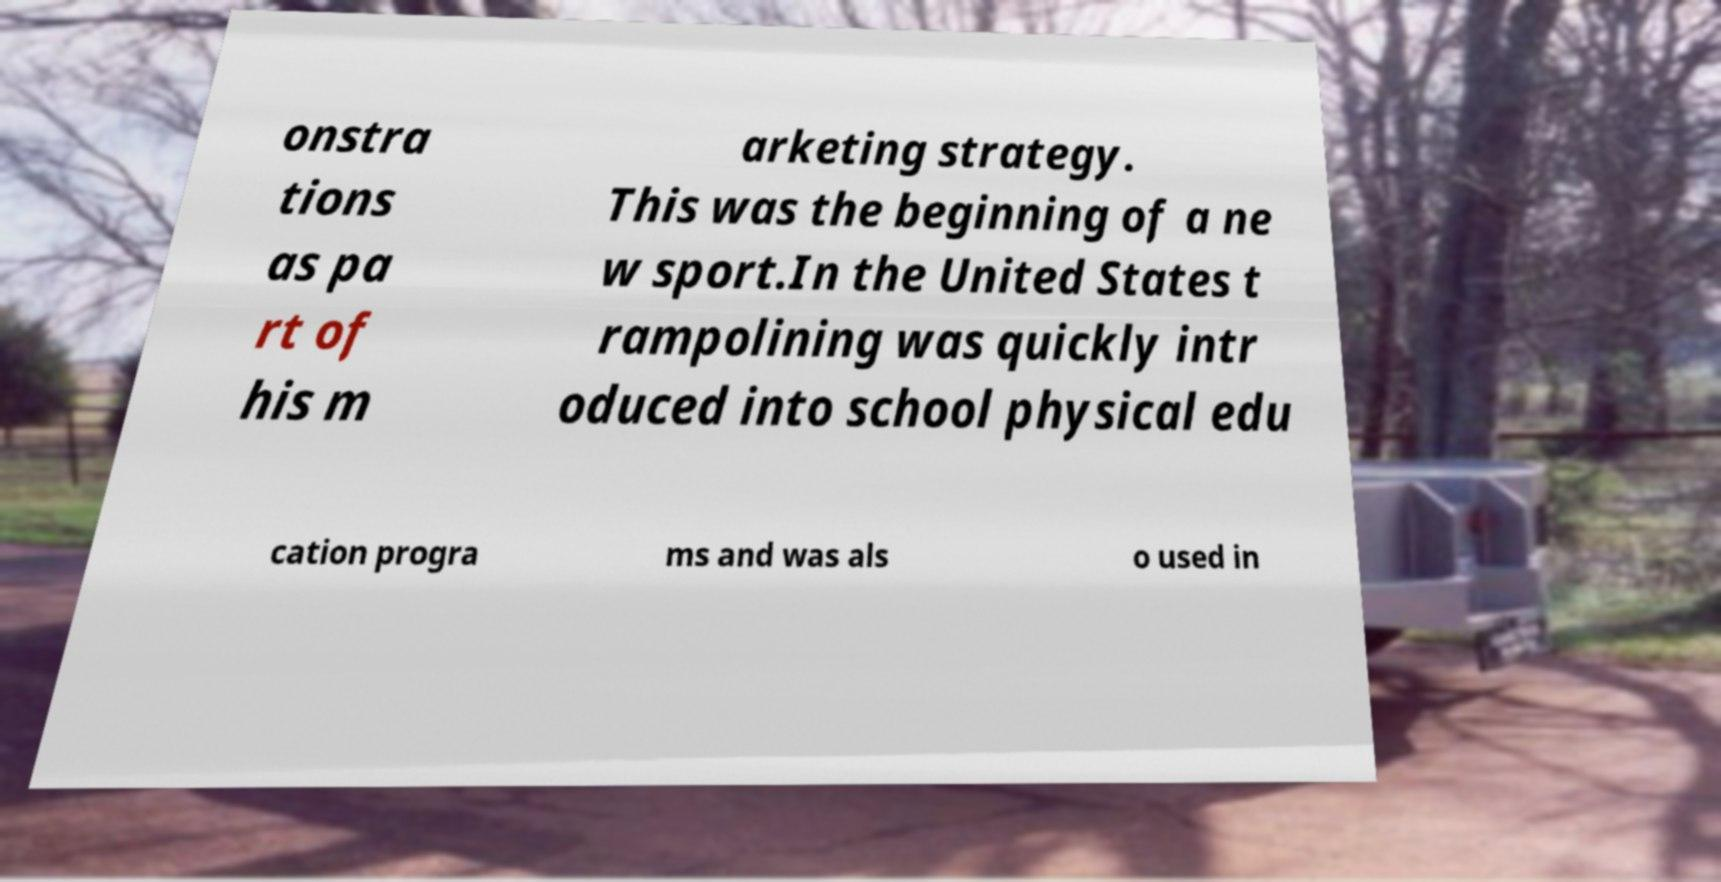For documentation purposes, I need the text within this image transcribed. Could you provide that? onstra tions as pa rt of his m arketing strategy. This was the beginning of a ne w sport.In the United States t rampolining was quickly intr oduced into school physical edu cation progra ms and was als o used in 